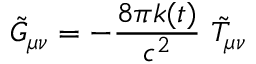Convert formula to latex. <formula><loc_0><loc_0><loc_500><loc_500>\tilde { G } _ { \mu \nu } = - \frac { 8 \pi k ( t ) } { c ^ { 2 } } \ \tilde { T } _ { \mu \nu }</formula> 